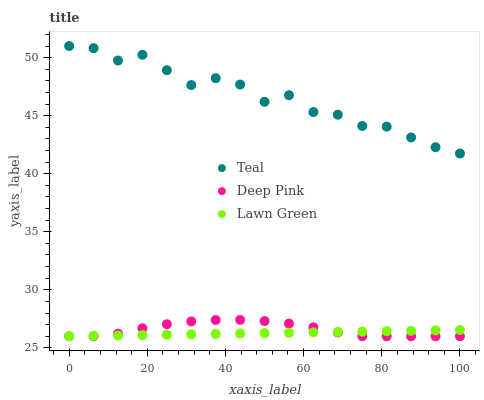Does Lawn Green have the minimum area under the curve?
Answer yes or no. Yes. Does Teal have the maximum area under the curve?
Answer yes or no. Yes. Does Deep Pink have the minimum area under the curve?
Answer yes or no. No. Does Deep Pink have the maximum area under the curve?
Answer yes or no. No. Is Lawn Green the smoothest?
Answer yes or no. Yes. Is Teal the roughest?
Answer yes or no. Yes. Is Deep Pink the smoothest?
Answer yes or no. No. Is Deep Pink the roughest?
Answer yes or no. No. Does Lawn Green have the lowest value?
Answer yes or no. Yes. Does Teal have the lowest value?
Answer yes or no. No. Does Teal have the highest value?
Answer yes or no. Yes. Does Deep Pink have the highest value?
Answer yes or no. No. Is Lawn Green less than Teal?
Answer yes or no. Yes. Is Teal greater than Lawn Green?
Answer yes or no. Yes. Does Lawn Green intersect Deep Pink?
Answer yes or no. Yes. Is Lawn Green less than Deep Pink?
Answer yes or no. No. Is Lawn Green greater than Deep Pink?
Answer yes or no. No. Does Lawn Green intersect Teal?
Answer yes or no. No. 